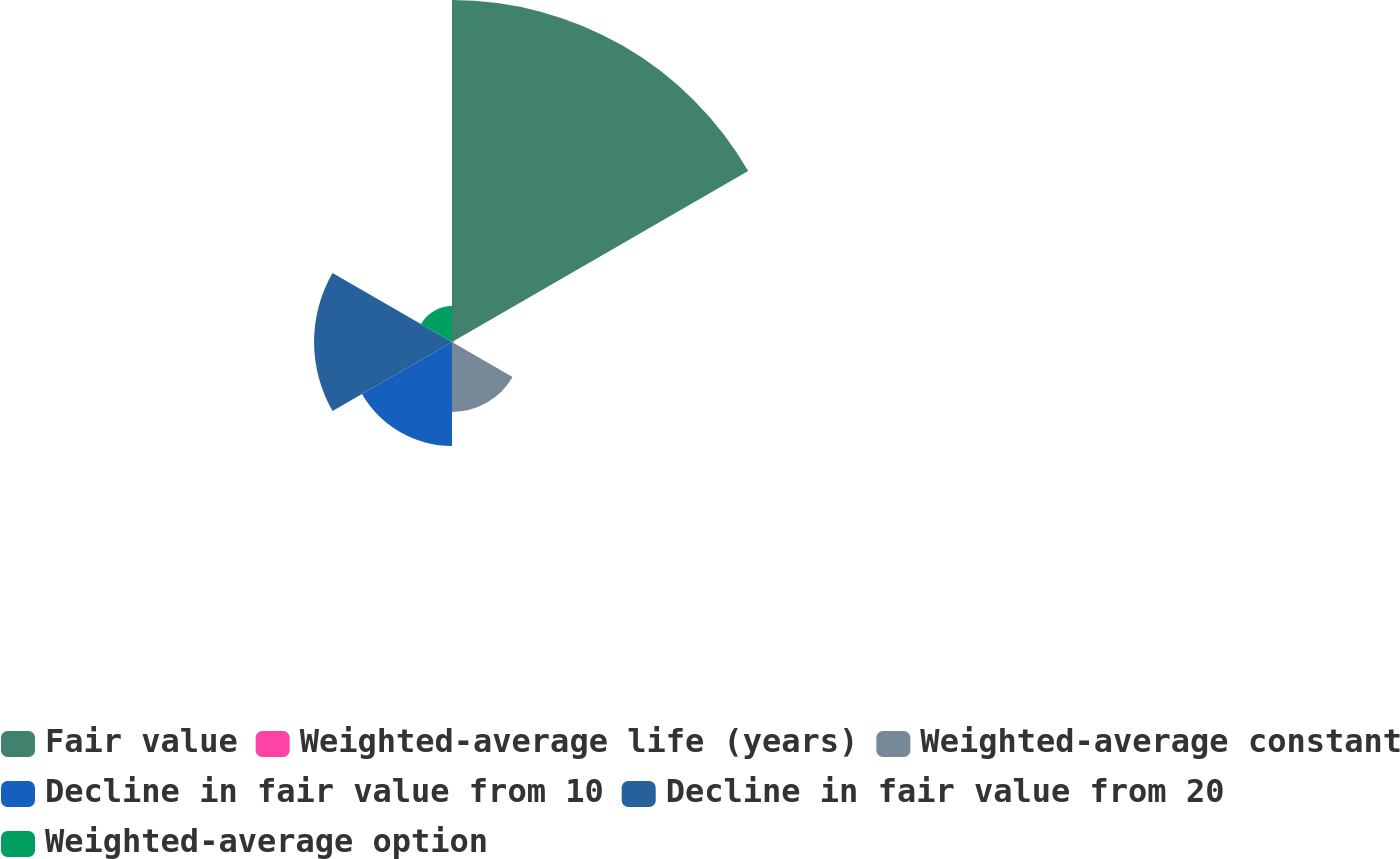Convert chart. <chart><loc_0><loc_0><loc_500><loc_500><pie_chart><fcel>Fair value<fcel>Weighted-average life (years)<fcel>Weighted-average constant<fcel>Decline in fair value from 10<fcel>Decline in fair value from 20<fcel>Weighted-average option<nl><fcel>49.44%<fcel>0.28%<fcel>10.11%<fcel>15.03%<fcel>19.94%<fcel>5.19%<nl></chart> 